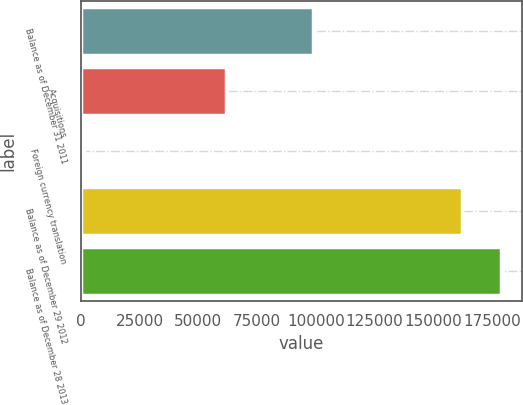<chart> <loc_0><loc_0><loc_500><loc_500><bar_chart><fcel>Balance as of December 31 2011<fcel>Acquisitions<fcel>Foreign currency translation<fcel>Balance as of December 29 2012<fcel>Balance as of December 28 2013<nl><fcel>98860<fcel>61788<fcel>1476<fcel>162124<fcel>178943<nl></chart> 